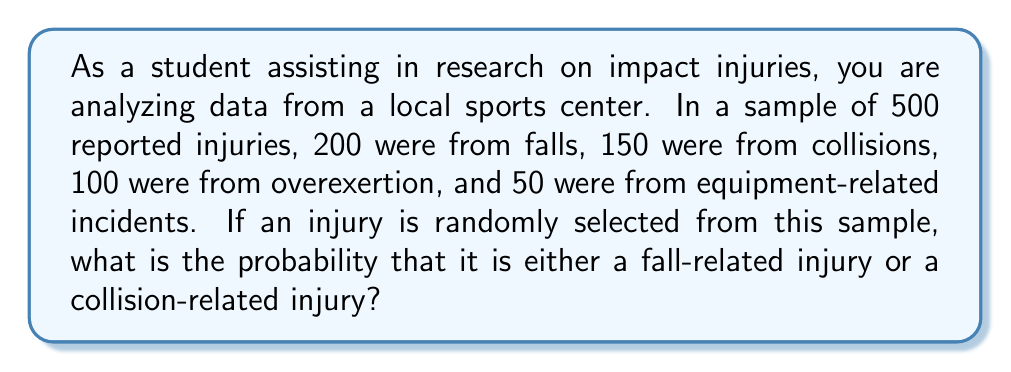Teach me how to tackle this problem. To solve this problem, we need to use the concept of probability and the addition rule for mutually exclusive events. Let's break it down step-by-step:

1. First, let's identify the total number of injuries and the number of injuries for each category:
   Total injuries: 500
   Fall-related injuries: 200
   Collision-related injuries: 150

2. Calculate the probability of a fall-related injury:
   $$P(\text{Fall}) = \frac{\text{Number of fall injuries}}{\text{Total number of injuries}} = \frac{200}{500} = \frac{2}{5} = 0.4$$

3. Calculate the probability of a collision-related injury:
   $$P(\text{Collision}) = \frac{\text{Number of collision injuries}}{\text{Total number of injuries}} = \frac{150}{500} = \frac{3}{10} = 0.3$$

4. Since we want the probability of either a fall-related injury or a collision-related injury, and these events are mutually exclusive (an injury cannot be both at the same time), we use the addition rule:

   $$P(\text{Fall or Collision}) = P(\text{Fall}) + P(\text{Collision})$$

5. Substitute the values:
   $$P(\text{Fall or Collision}) = 0.4 + 0.3 = 0.7$$

Therefore, the probability that a randomly selected injury is either a fall-related injury or a collision-related injury is 0.7 or 70%.
Answer: The probability is 0.7 or 70%. 